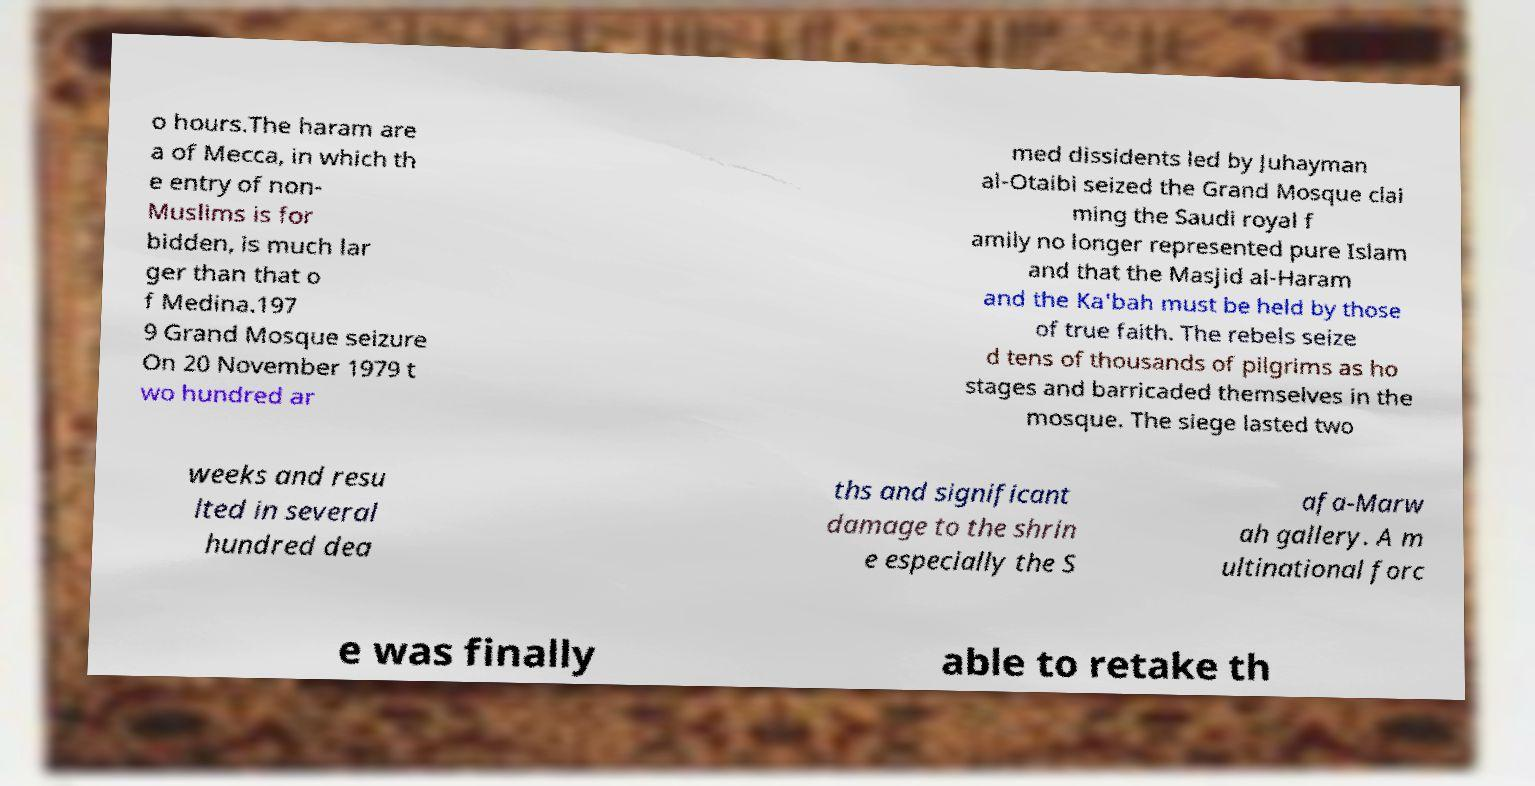Could you extract and type out the text from this image? o hours.The haram are a of Mecca, in which th e entry of non- Muslims is for bidden, is much lar ger than that o f Medina.197 9 Grand Mosque seizure On 20 November 1979 t wo hundred ar med dissidents led by Juhayman al-Otaibi seized the Grand Mosque clai ming the Saudi royal f amily no longer represented pure Islam and that the Masjid al-Haram and the Ka'bah must be held by those of true faith. The rebels seize d tens of thousands of pilgrims as ho stages and barricaded themselves in the mosque. The siege lasted two weeks and resu lted in several hundred dea ths and significant damage to the shrin e especially the S afa-Marw ah gallery. A m ultinational forc e was finally able to retake th 